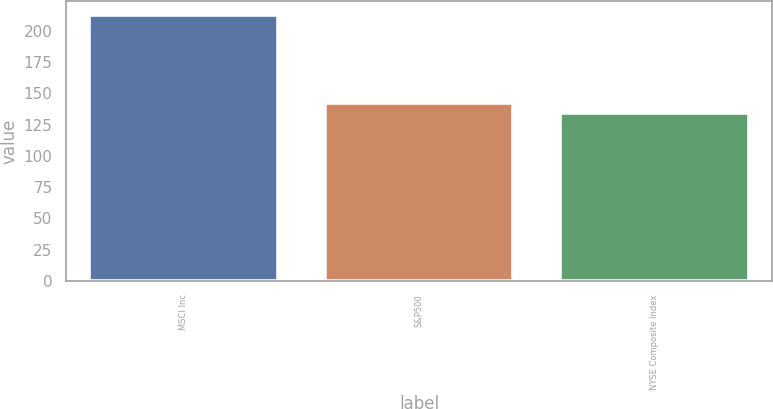<chart> <loc_0><loc_0><loc_500><loc_500><bar_chart><fcel>MSCI Inc<fcel>S&P500<fcel>NYSE Composite Index<nl><fcel>213<fcel>141.9<fcel>134<nl></chart> 